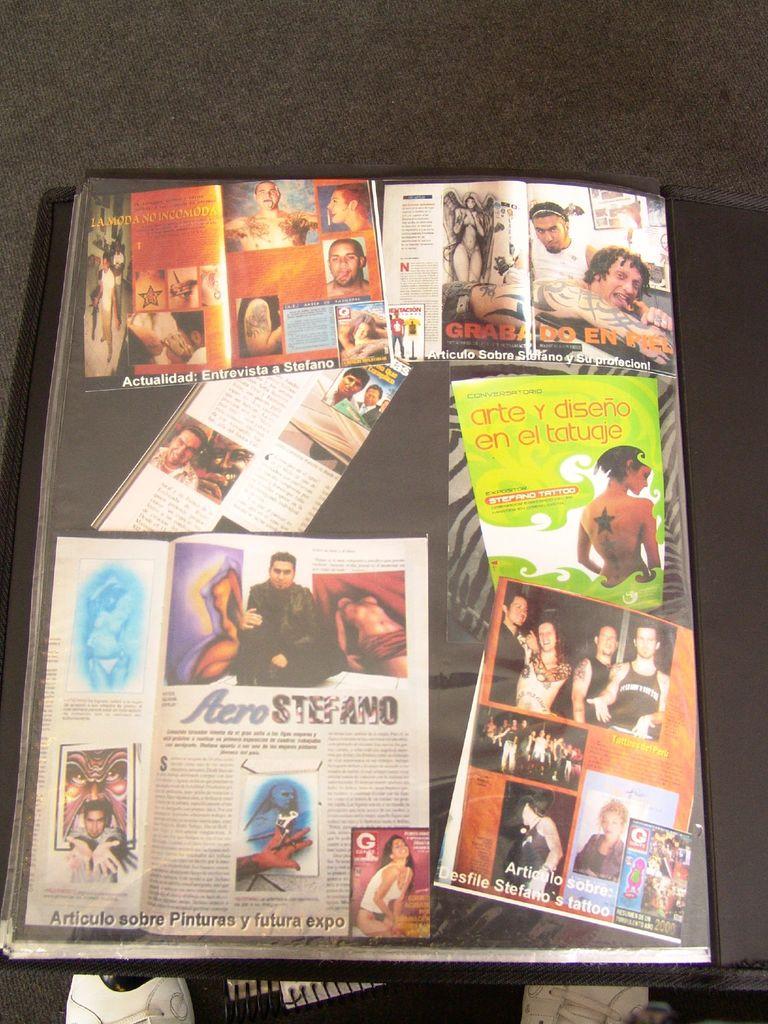What is the last word of the bottom row on the article in the bottom left?
Your response must be concise. Expo. What is the title of the article at the bottom left?
Give a very brief answer. Aero stefano. 